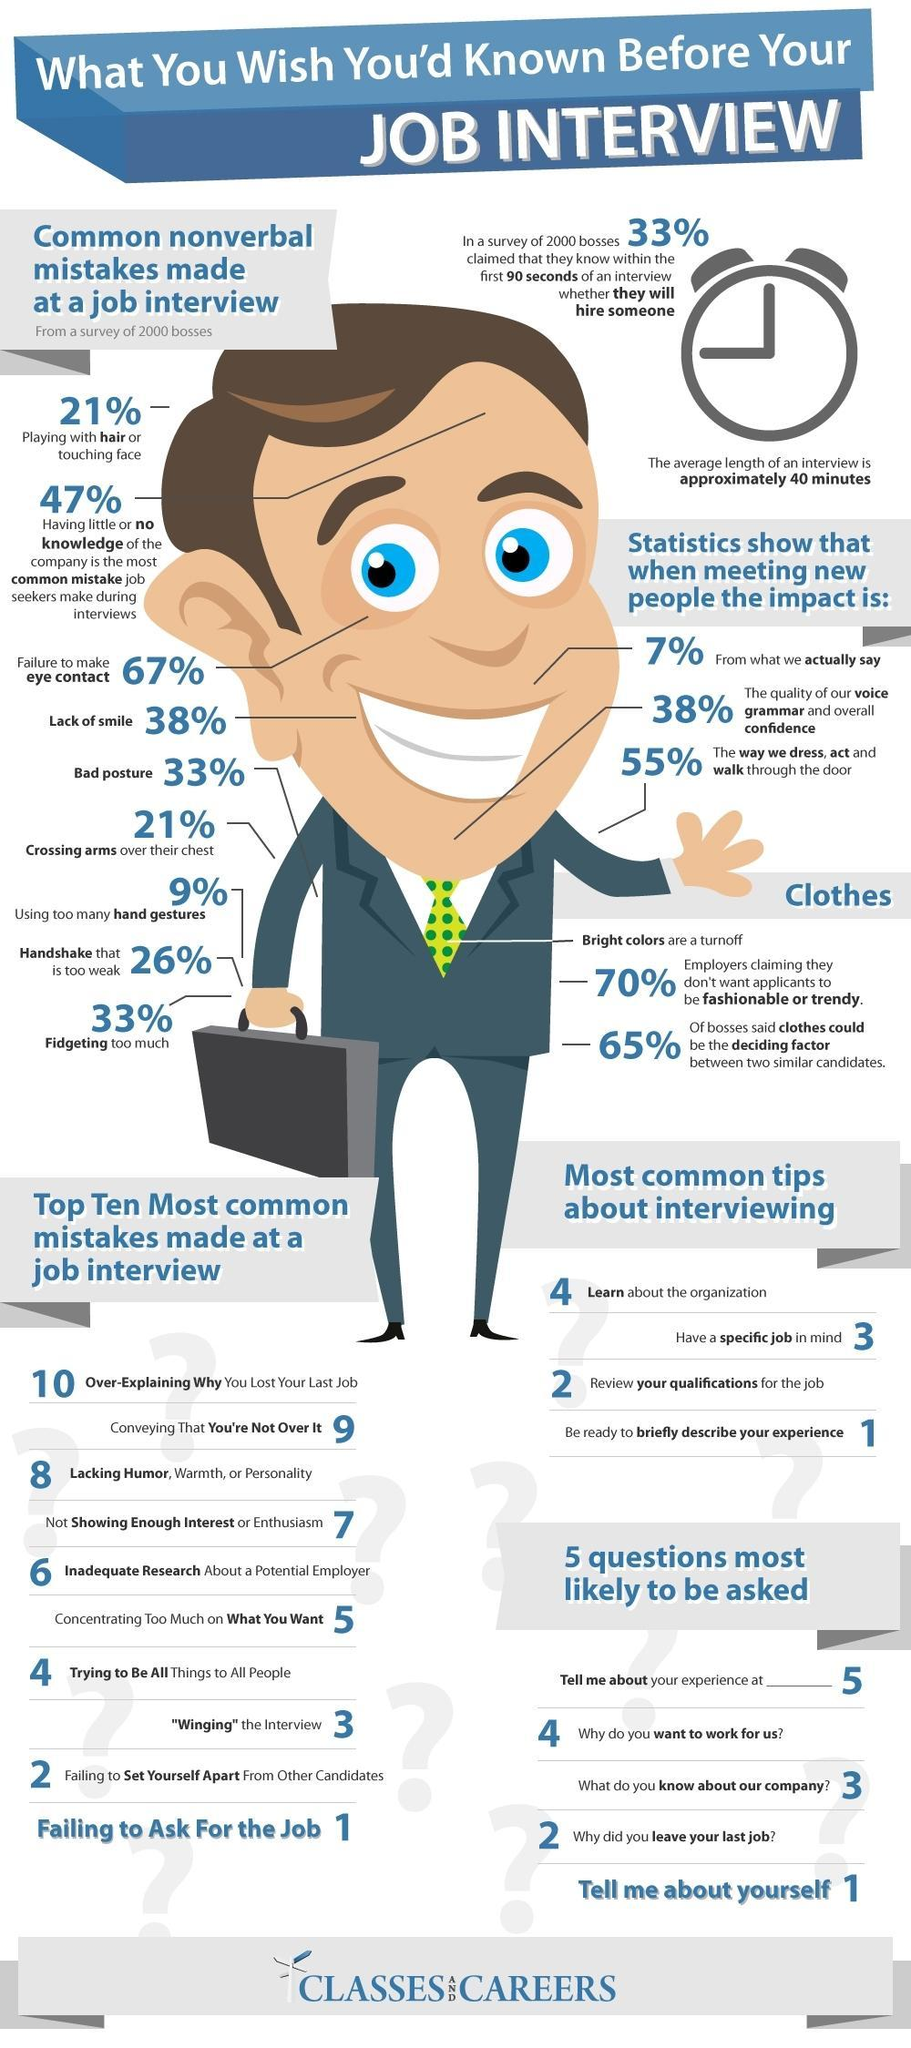Which type of coloured clothes are perfect for a job interview- bright or light?
Answer the question with a short phrase. light What is the inverse percentage of bosses who claimed clothes could be the deciding factor in selecting similar candidates? 35 What is the inverse of people playing with hair in a job interview? 79 What is the most common mistake of job seekers? Having little or no knowledge of the company What is the inverse of people who lack smile in an interview? 62 What is probably the first question of a job interview? Tell me about Yourself Which mistake ranks first in the most common mistakes made during job interview? Failing to ask for the job 